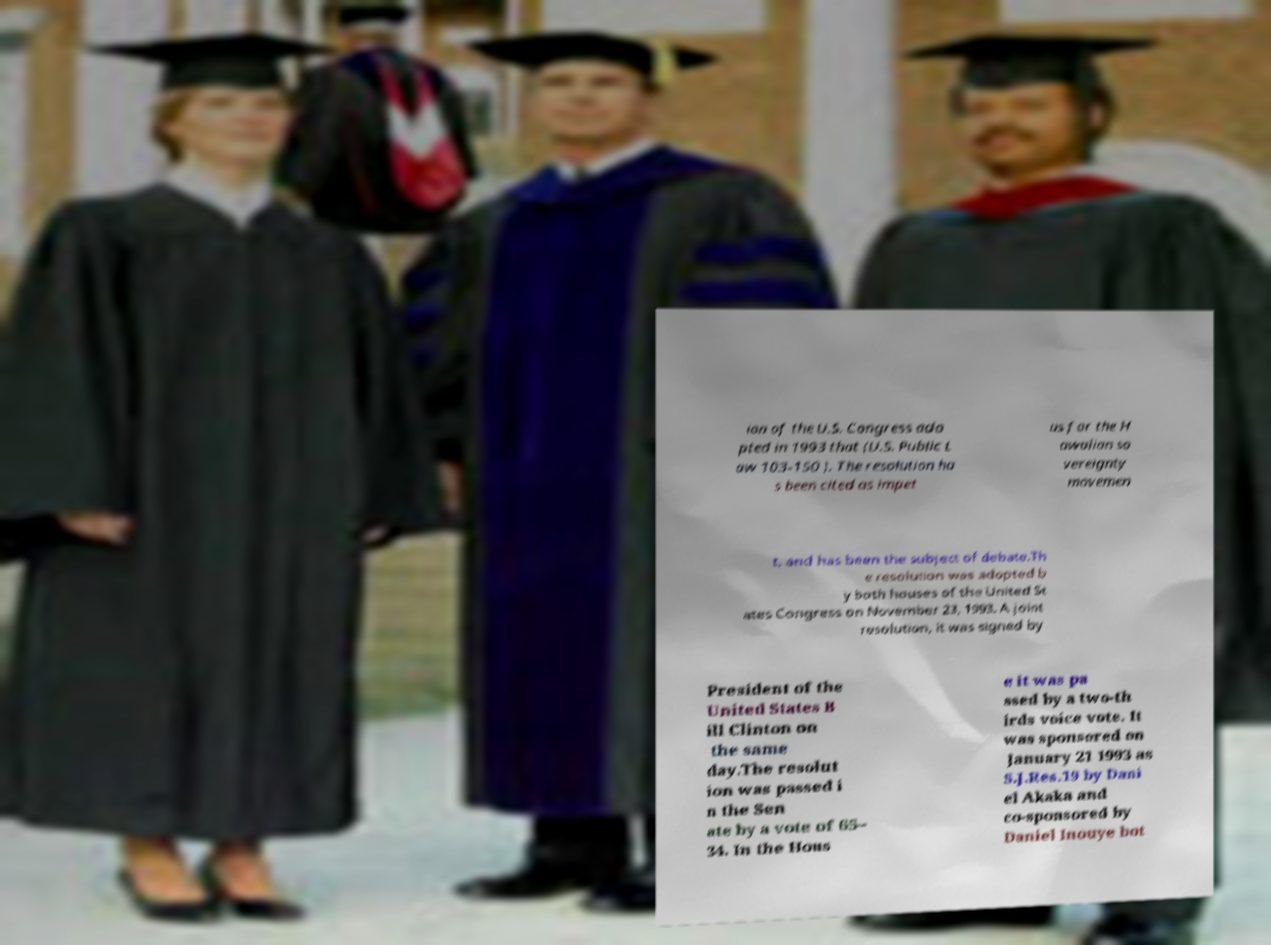I need the written content from this picture converted into text. Can you do that? ion of the U.S. Congress ado pted in 1993 that (U.S. Public L aw 103-150 ). The resolution ha s been cited as impet us for the H awaiian so vereignty movemen t, and has been the subject of debate.Th e resolution was adopted b y both houses of the United St ates Congress on November 23, 1993. A joint resolution, it was signed by President of the United States B ill Clinton on the same day.The resolut ion was passed i n the Sen ate by a vote of 65– 34. In the Hous e it was pa ssed by a two-th irds voice vote. It was sponsored on January 21 1993 as S.J.Res.19 by Dani el Akaka and co-sponsored by Daniel Inouye bot 